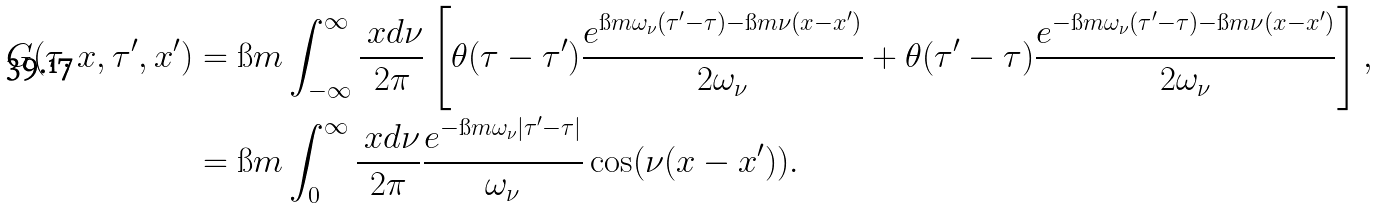Convert formula to latex. <formula><loc_0><loc_0><loc_500><loc_500>G ( \tau , x , \tau ^ { \prime } , x ^ { \prime } ) & = \i m \int _ { - \infty } ^ { \infty } \frac { \ x d \nu } { 2 \pi } \left [ \theta ( \tau - \tau ^ { \prime } ) \frac { e ^ { \i m \omega _ { \nu } ( \tau ^ { \prime } - \tau ) - \i m \nu ( x - x ^ { \prime } ) } } { 2 \omega _ { \nu } } + \theta ( \tau ^ { \prime } - \tau ) \frac { e ^ { - \i m \omega _ { \nu } ( \tau ^ { \prime } - \tau ) - \i m \nu ( x - x ^ { \prime } ) } } { 2 \omega _ { \nu } } \right ] , \\ & = \i m \int _ { 0 } ^ { \infty } \frac { \ x d \nu } { 2 \pi } \frac { e ^ { - \i m \omega _ { \nu } | \tau ^ { \prime } - \tau | } } { \omega _ { \nu } } \cos ( \nu ( x - x ^ { \prime } ) ) .</formula> 